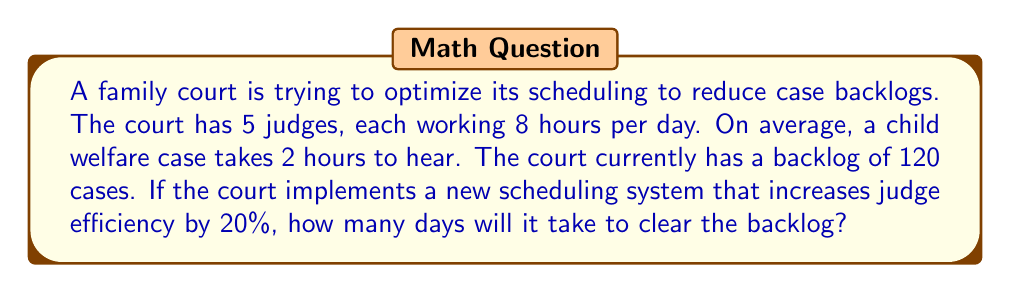Help me with this question. Let's approach this problem step-by-step:

1. Calculate the current capacity:
   * Number of judges: 5
   * Hours per judge per day: 8
   * Total judge-hours per day: $5 \times 8 = 40$ hours

2. Calculate the number of cases that can be heard per day currently:
   * Time per case: 2 hours
   * Cases per day = $\frac{\text{Total judge-hours}}{\text{Time per case}} = \frac{40}{2} = 20$ cases

3. Calculate the new capacity with 20% increased efficiency:
   * New capacity = Current capacity $\times$ (1 + Efficiency increase)
   * New capacity = $20 \times (1 + 0.20) = 20 \times 1.20 = 24$ cases per day

4. Calculate the number of days to clear the backlog:
   * Backlog: 120 cases
   * Days to clear backlog = $\frac{\text{Number of backlogged cases}}{\text{Cases cleared per day}}$
   * Days to clear backlog = $\frac{120}{24} = 5$ days

Therefore, with the new scheduling system, it will take 5 days to clear the backlog of child welfare cases.
Answer: 5 days 